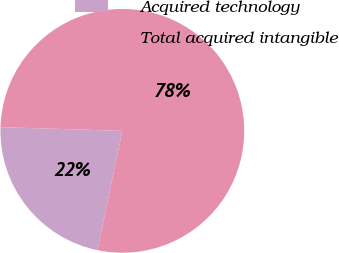Convert chart to OTSL. <chart><loc_0><loc_0><loc_500><loc_500><pie_chart><fcel>Acquired technology<fcel>Total acquired intangible<nl><fcel>22.22%<fcel>77.78%<nl></chart> 